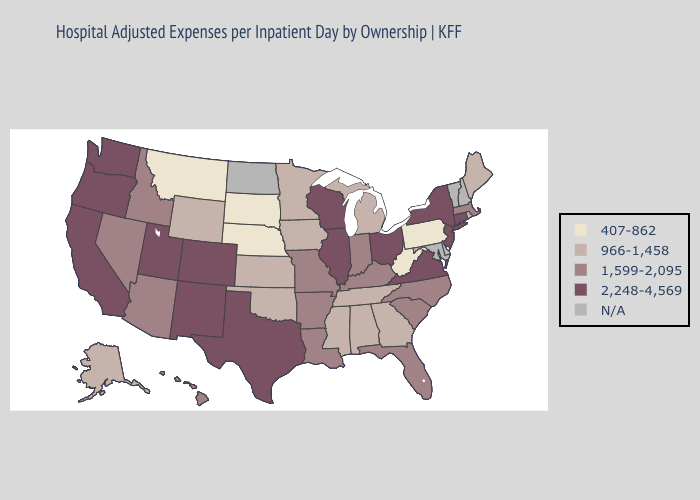What is the value of North Dakota?
Concise answer only. N/A. Does the map have missing data?
Quick response, please. Yes. Among the states that border Louisiana , does Arkansas have the lowest value?
Quick response, please. No. What is the value of New Hampshire?
Short answer required. N/A. Which states have the lowest value in the USA?
Concise answer only. Montana, Nebraska, Pennsylvania, South Dakota, West Virginia. What is the value of Montana?
Short answer required. 407-862. Is the legend a continuous bar?
Be succinct. No. What is the lowest value in the USA?
Write a very short answer. 407-862. Name the states that have a value in the range 407-862?
Quick response, please. Montana, Nebraska, Pennsylvania, South Dakota, West Virginia. Name the states that have a value in the range N/A?
Answer briefly. Delaware, Maryland, New Hampshire, North Dakota, Rhode Island, Vermont. Name the states that have a value in the range N/A?
Be succinct. Delaware, Maryland, New Hampshire, North Dakota, Rhode Island, Vermont. Among the states that border Minnesota , which have the highest value?
Be succinct. Wisconsin. What is the lowest value in the USA?
Be succinct. 407-862. 